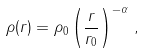Convert formula to latex. <formula><loc_0><loc_0><loc_500><loc_500>\rho ( r ) = \rho _ { 0 } \left ( \frac { r } { r _ { 0 } } \right ) ^ { - \alpha } \, ,</formula> 